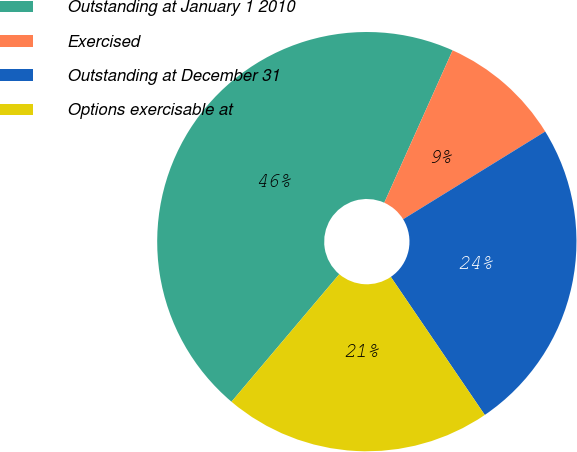Convert chart to OTSL. <chart><loc_0><loc_0><loc_500><loc_500><pie_chart><fcel>Outstanding at January 1 2010<fcel>Exercised<fcel>Outstanding at December 31<fcel>Options exercisable at<nl><fcel>45.54%<fcel>9.49%<fcel>24.29%<fcel>20.68%<nl></chart> 